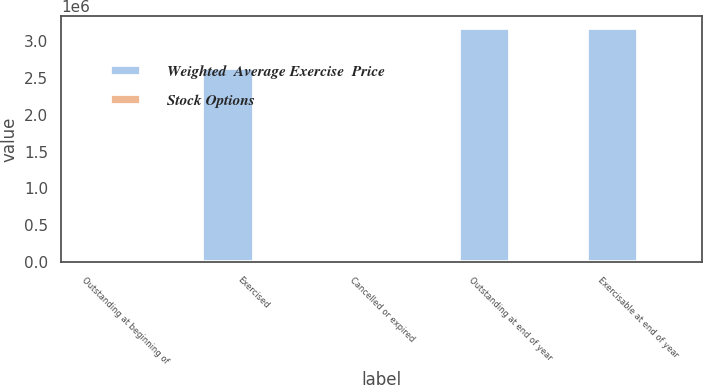Convert chart. <chart><loc_0><loc_0><loc_500><loc_500><stacked_bar_chart><ecel><fcel>Outstanding at beginning of<fcel>Exercised<fcel>Cancelled or expired<fcel>Outstanding at end of year<fcel>Exercisable at end of year<nl><fcel>Weighted  Average Exercise  Price<fcel>19.53<fcel>2.6348e+06<fcel>38000<fcel>3.18416e+06<fcel>3.18416e+06<nl><fcel>Stock Options<fcel>17.25<fcel>14.47<fcel>18.98<fcel>19.53<fcel>19.53<nl></chart> 